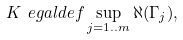Convert formula to latex. <formula><loc_0><loc_0><loc_500><loc_500>K \ e g a l d e f \sup _ { j = 1 . . m } \aleph ( \Gamma _ { j } ) ,</formula> 